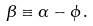<formula> <loc_0><loc_0><loc_500><loc_500>\beta \equiv \alpha - \phi \, .</formula> 